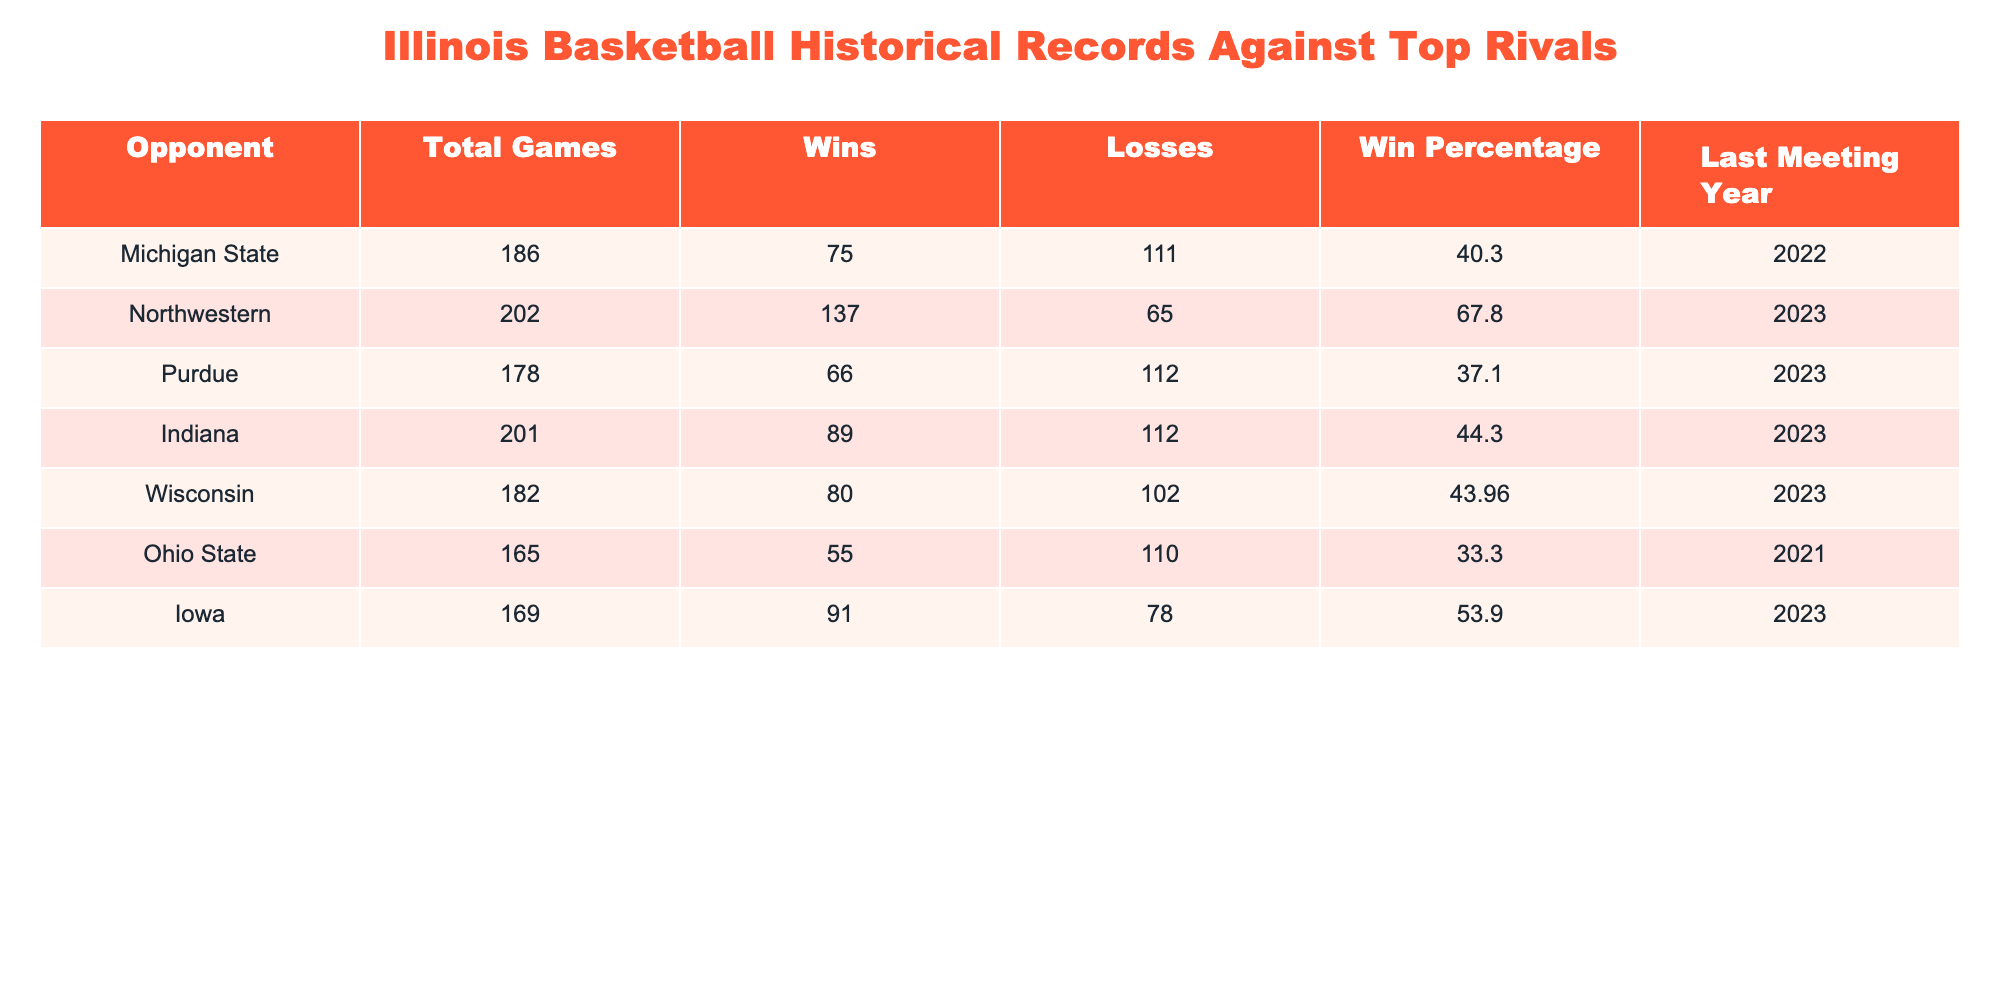What is Illinois' win-loss record against Michigan State? The table shows that Illinois has played a total of 186 games against Michigan State, with 75 wins and 111 losses. This provides the win-loss record as 75-111.
Answer: 75-111 Which opponent has the highest win percentage against Illinois? To determine this, we compare the win percentages of all opponents. Northwestern has the highest win percentage at 67.8%.
Answer: Northwestern What is the total number of wins against Purdue and Ohio State combined? The table shows that Illinois has 66 wins against Purdue and 55 wins against Ohio State. By adding these together (66 + 55), we find there are a total of 121 wins.
Answer: 121 Is Illinois' win-loss record against Indiana better than against Iowa? Against Indiana, Illinois has 89 wins and 112 losses, giving a win percentage of 44.3%. Against Iowa, Illinois has 91 wins and 78 losses, leading to a win percentage of 53.9%. Comparing these percentages shows that Illinois has a better record against Iowa.
Answer: Yes What is the average win percentage of Illinois against these top rivals? To find the average win percentage, we sum the win percentages of all opponents: 40.3 + 67.8 + 37.1 + 44.3 + 43.96 + 33.3 + 53.9 = 317.6. Since there are 7 opponents, we divide this sum by 7 to find the average win percentage (317.6 / 7) = 45.37%.
Answer: 45.37% How many more losses does Illinois have against Wisconsin than Iowa? Illinois has 102 losses against Wisconsin and 78 losses against Iowa. By subtracting these numbers (102 - 78), we find that Illinois has 24 more losses against Wisconsin.
Answer: 24 In what year was the last meeting between Illinois and Ohio State? According to the table, the last meeting between Illinois and Ohio State was in the year 2021.
Answer: 2021 Which opponent has had the most games played against Illinois? Looking at the Total Games column, Michigan State has 186 games played against Illinois, which is the highest number among all opponents.
Answer: Michigan State How many wins does Illinois have against both Michigan State and Indiana combined? Illinois has 75 wins against Michigan State and 89 against Indiana. Adding these together (75 + 89), Illinois has a total of 164 wins against both teams.
Answer: 164 